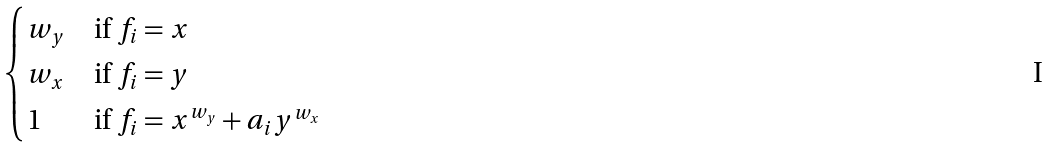Convert formula to latex. <formula><loc_0><loc_0><loc_500><loc_500>\begin{cases} w _ { y } & \text {if } f _ { i } = x \\ w _ { x } & \text {if } f _ { i } = y \\ 1 & \text {if } f _ { i } = x ^ { w _ { y } } + a _ { i } y ^ { w _ { x } } \end{cases}</formula> 